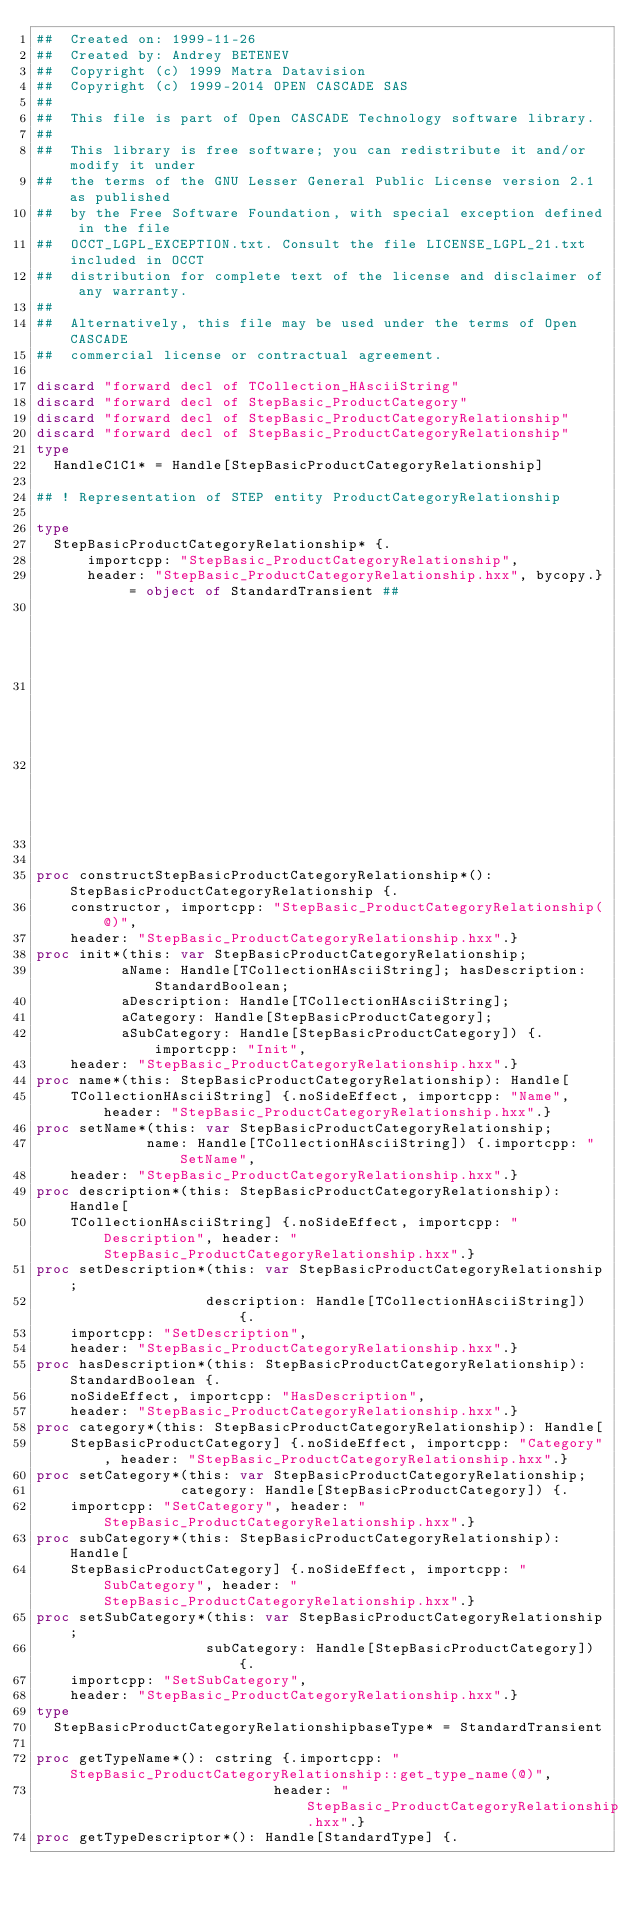Convert code to text. <code><loc_0><loc_0><loc_500><loc_500><_Nim_>##  Created on: 1999-11-26
##  Created by: Andrey BETENEV
##  Copyright (c) 1999 Matra Datavision
##  Copyright (c) 1999-2014 OPEN CASCADE SAS
##
##  This file is part of Open CASCADE Technology software library.
##
##  This library is free software; you can redistribute it and/or modify it under
##  the terms of the GNU Lesser General Public License version 2.1 as published
##  by the Free Software Foundation, with special exception defined in the file
##  OCCT_LGPL_EXCEPTION.txt. Consult the file LICENSE_LGPL_21.txt included in OCCT
##  distribution for complete text of the license and disclaimer of any warranty.
##
##  Alternatively, this file may be used under the terms of Open CASCADE
##  commercial license or contractual agreement.

discard "forward decl of TCollection_HAsciiString"
discard "forward decl of StepBasic_ProductCategory"
discard "forward decl of StepBasic_ProductCategoryRelationship"
discard "forward decl of StepBasic_ProductCategoryRelationship"
type
  HandleC1C1* = Handle[StepBasicProductCategoryRelationship]

## ! Representation of STEP entity ProductCategoryRelationship

type
  StepBasicProductCategoryRelationship* {.
      importcpp: "StepBasic_ProductCategoryRelationship",
      header: "StepBasic_ProductCategoryRelationship.hxx", bycopy.} = object of StandardTransient ##
                                                                                           ## !
                                                                                           ## Empty
                                                                                           ## constructor


proc constructStepBasicProductCategoryRelationship*(): StepBasicProductCategoryRelationship {.
    constructor, importcpp: "StepBasic_ProductCategoryRelationship(@)",
    header: "StepBasic_ProductCategoryRelationship.hxx".}
proc init*(this: var StepBasicProductCategoryRelationship;
          aName: Handle[TCollectionHAsciiString]; hasDescription: StandardBoolean;
          aDescription: Handle[TCollectionHAsciiString];
          aCategory: Handle[StepBasicProductCategory];
          aSubCategory: Handle[StepBasicProductCategory]) {.importcpp: "Init",
    header: "StepBasic_ProductCategoryRelationship.hxx".}
proc name*(this: StepBasicProductCategoryRelationship): Handle[
    TCollectionHAsciiString] {.noSideEffect, importcpp: "Name", header: "StepBasic_ProductCategoryRelationship.hxx".}
proc setName*(this: var StepBasicProductCategoryRelationship;
             name: Handle[TCollectionHAsciiString]) {.importcpp: "SetName",
    header: "StepBasic_ProductCategoryRelationship.hxx".}
proc description*(this: StepBasicProductCategoryRelationship): Handle[
    TCollectionHAsciiString] {.noSideEffect, importcpp: "Description", header: "StepBasic_ProductCategoryRelationship.hxx".}
proc setDescription*(this: var StepBasicProductCategoryRelationship;
                    description: Handle[TCollectionHAsciiString]) {.
    importcpp: "SetDescription",
    header: "StepBasic_ProductCategoryRelationship.hxx".}
proc hasDescription*(this: StepBasicProductCategoryRelationship): StandardBoolean {.
    noSideEffect, importcpp: "HasDescription",
    header: "StepBasic_ProductCategoryRelationship.hxx".}
proc category*(this: StepBasicProductCategoryRelationship): Handle[
    StepBasicProductCategory] {.noSideEffect, importcpp: "Category", header: "StepBasic_ProductCategoryRelationship.hxx".}
proc setCategory*(this: var StepBasicProductCategoryRelationship;
                 category: Handle[StepBasicProductCategory]) {.
    importcpp: "SetCategory", header: "StepBasic_ProductCategoryRelationship.hxx".}
proc subCategory*(this: StepBasicProductCategoryRelationship): Handle[
    StepBasicProductCategory] {.noSideEffect, importcpp: "SubCategory", header: "StepBasic_ProductCategoryRelationship.hxx".}
proc setSubCategory*(this: var StepBasicProductCategoryRelationship;
                    subCategory: Handle[StepBasicProductCategory]) {.
    importcpp: "SetSubCategory",
    header: "StepBasic_ProductCategoryRelationship.hxx".}
type
  StepBasicProductCategoryRelationshipbaseType* = StandardTransient

proc getTypeName*(): cstring {.importcpp: "StepBasic_ProductCategoryRelationship::get_type_name(@)",
                            header: "StepBasic_ProductCategoryRelationship.hxx".}
proc getTypeDescriptor*(): Handle[StandardType] {.</code> 